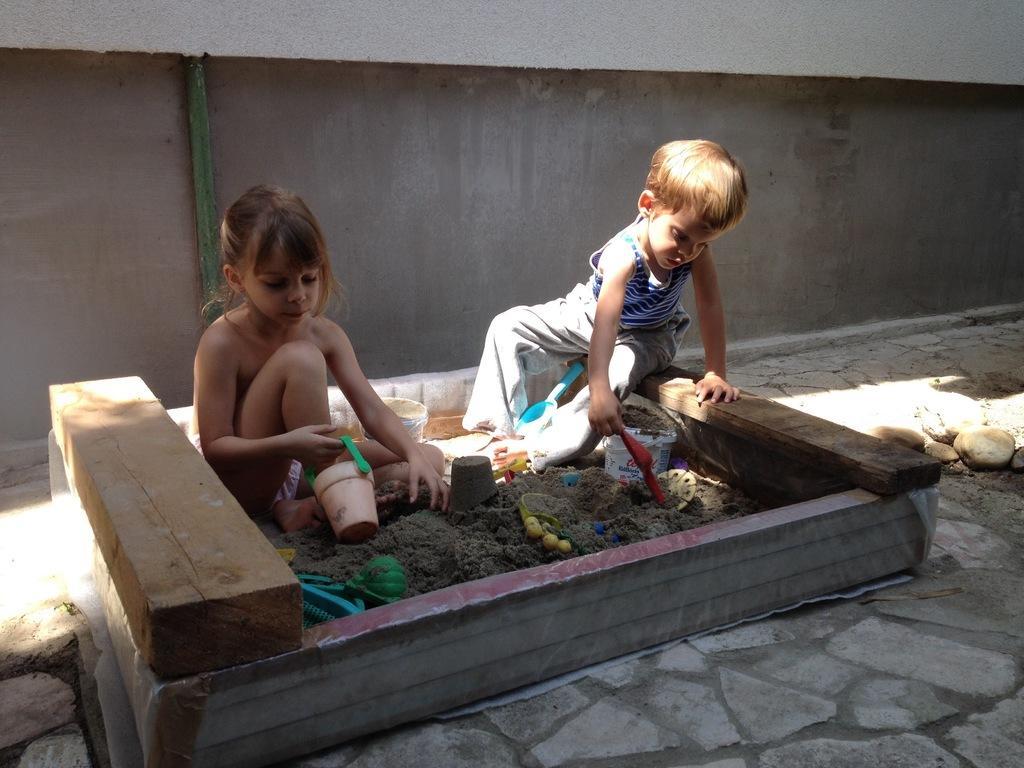Can you describe this image briefly? In the center of the image we can see children playing with mud. There are toys. In the background there is a wall. 